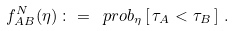Convert formula to latex. <formula><loc_0><loc_0><loc_500><loc_500>f _ { A B } ^ { N } ( \eta ) \, \colon = \, \ p r o b _ { \eta } \left [ \, \tau _ { A } < \tau _ { B } \, \right ] \, .</formula> 